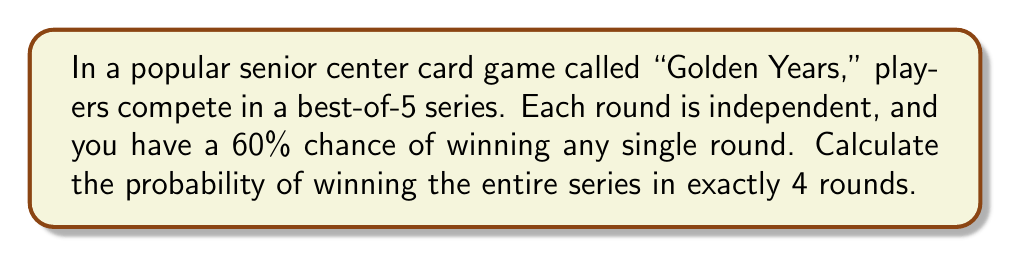Help me with this question. Let's approach this step-by-step:

1) To win in exactly 4 rounds, you need to win 3 out of the first 3 rounds and then win the 4th round, or win 3 out of the first 4 rounds and then win the 5th round.

2) Let's calculate the probability of winning the first scenario (winning the first 3 rounds and the 4th):
   $$P(\text{Win first 3 and 4th}) = 0.6 \times 0.6 \times 0.6 \times 0.6 = 0.6^4 = 0.1296$$

3) Now, let's calculate the probability of winning 3 out of the first 4 rounds and then winning the 5th:
   - We need to use the combination formula to account for all possible ways to win 3 out of 4 rounds
   - There are $\binom{4}{3} = 4$ ways to win 3 out of 4 rounds
   - The probability for each of these scenarios is $0.6^3 \times 0.4^1 = 0.0864$
   - Then we multiply by the probability of winning the 5th round (0.6)

   $$P(\text{Win 3 of 4 and 5th}) = 4 \times 0.0864 \times 0.6 = 0.20736$$

4) The total probability is the sum of these two scenarios:
   $$P(\text{Win in exactly 4 rounds}) = 0.1296 + 0.20736 = 0.33696$$
Answer: $\frac{3369}{10000} \approx 0.3369$ 